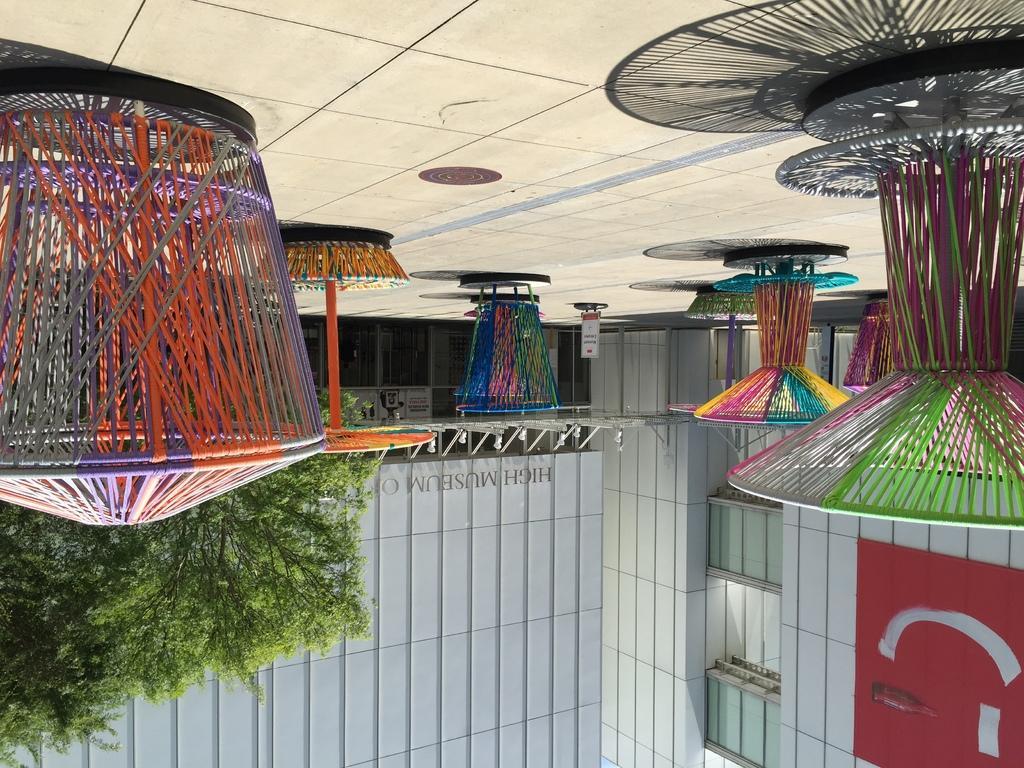In one or two sentences, can you explain what this image depicts? In this image I can see the colorful objects on the ground. In the background I can see the buildings and trees. 